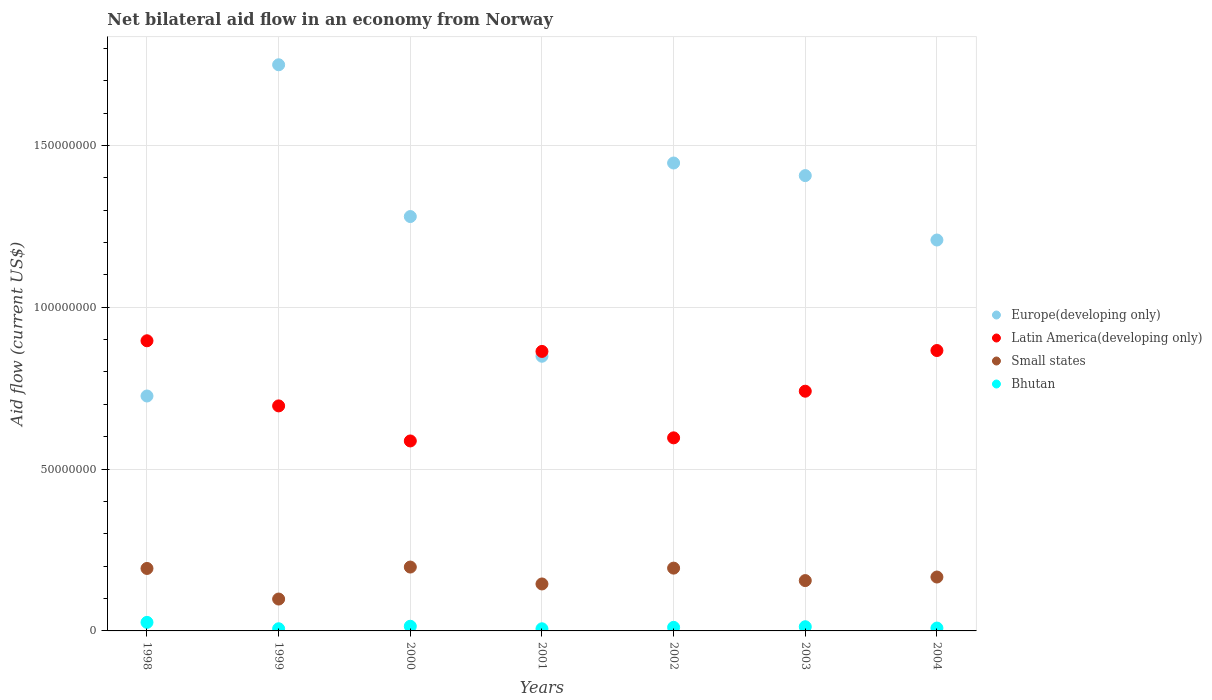How many different coloured dotlines are there?
Your answer should be very brief. 4. Is the number of dotlines equal to the number of legend labels?
Offer a very short reply. Yes. What is the net bilateral aid flow in Small states in 2001?
Keep it short and to the point. 1.45e+07. Across all years, what is the maximum net bilateral aid flow in Latin America(developing only)?
Offer a very short reply. 8.96e+07. What is the total net bilateral aid flow in Latin America(developing only) in the graph?
Keep it short and to the point. 5.25e+08. What is the difference between the net bilateral aid flow in Europe(developing only) in 1998 and that in 2002?
Provide a succinct answer. -7.20e+07. What is the difference between the net bilateral aid flow in Europe(developing only) in 2004 and the net bilateral aid flow in Bhutan in 2000?
Keep it short and to the point. 1.19e+08. What is the average net bilateral aid flow in Bhutan per year?
Provide a short and direct response. 1.24e+06. In the year 2000, what is the difference between the net bilateral aid flow in Europe(developing only) and net bilateral aid flow in Latin America(developing only)?
Ensure brevity in your answer.  6.93e+07. What is the ratio of the net bilateral aid flow in Small states in 1999 to that in 2003?
Offer a very short reply. 0.63. Is the difference between the net bilateral aid flow in Europe(developing only) in 1998 and 2004 greater than the difference between the net bilateral aid flow in Latin America(developing only) in 1998 and 2004?
Your answer should be very brief. No. What is the difference between the highest and the second highest net bilateral aid flow in Latin America(developing only)?
Your answer should be very brief. 3.01e+06. What is the difference between the highest and the lowest net bilateral aid flow in Small states?
Your answer should be very brief. 9.88e+06. Is it the case that in every year, the sum of the net bilateral aid flow in Bhutan and net bilateral aid flow in Europe(developing only)  is greater than the net bilateral aid flow in Latin America(developing only)?
Keep it short and to the point. No. Is the net bilateral aid flow in Latin America(developing only) strictly less than the net bilateral aid flow in Europe(developing only) over the years?
Provide a succinct answer. No. How many years are there in the graph?
Offer a very short reply. 7. What is the difference between two consecutive major ticks on the Y-axis?
Your answer should be very brief. 5.00e+07. Where does the legend appear in the graph?
Provide a succinct answer. Center right. How many legend labels are there?
Provide a succinct answer. 4. How are the legend labels stacked?
Provide a succinct answer. Vertical. What is the title of the graph?
Ensure brevity in your answer.  Net bilateral aid flow in an economy from Norway. Does "Cameroon" appear as one of the legend labels in the graph?
Offer a terse response. No. What is the Aid flow (current US$) in Europe(developing only) in 1998?
Make the answer very short. 7.26e+07. What is the Aid flow (current US$) in Latin America(developing only) in 1998?
Give a very brief answer. 8.96e+07. What is the Aid flow (current US$) of Small states in 1998?
Your answer should be very brief. 1.93e+07. What is the Aid flow (current US$) in Bhutan in 1998?
Offer a very short reply. 2.64e+06. What is the Aid flow (current US$) of Europe(developing only) in 1999?
Your response must be concise. 1.75e+08. What is the Aid flow (current US$) of Latin America(developing only) in 1999?
Provide a short and direct response. 6.95e+07. What is the Aid flow (current US$) of Small states in 1999?
Provide a short and direct response. 9.85e+06. What is the Aid flow (current US$) in Bhutan in 1999?
Your response must be concise. 6.70e+05. What is the Aid flow (current US$) of Europe(developing only) in 2000?
Offer a very short reply. 1.28e+08. What is the Aid flow (current US$) of Latin America(developing only) in 2000?
Make the answer very short. 5.87e+07. What is the Aid flow (current US$) of Small states in 2000?
Your answer should be very brief. 1.97e+07. What is the Aid flow (current US$) in Bhutan in 2000?
Your answer should be very brief. 1.44e+06. What is the Aid flow (current US$) of Europe(developing only) in 2001?
Ensure brevity in your answer.  8.49e+07. What is the Aid flow (current US$) in Latin America(developing only) in 2001?
Your response must be concise. 8.64e+07. What is the Aid flow (current US$) of Small states in 2001?
Provide a short and direct response. 1.45e+07. What is the Aid flow (current US$) in Europe(developing only) in 2002?
Keep it short and to the point. 1.45e+08. What is the Aid flow (current US$) in Latin America(developing only) in 2002?
Your answer should be very brief. 5.96e+07. What is the Aid flow (current US$) in Small states in 2002?
Your response must be concise. 1.94e+07. What is the Aid flow (current US$) in Bhutan in 2002?
Offer a very short reply. 1.10e+06. What is the Aid flow (current US$) of Europe(developing only) in 2003?
Ensure brevity in your answer.  1.41e+08. What is the Aid flow (current US$) in Latin America(developing only) in 2003?
Your answer should be very brief. 7.41e+07. What is the Aid flow (current US$) of Small states in 2003?
Ensure brevity in your answer.  1.56e+07. What is the Aid flow (current US$) in Bhutan in 2003?
Ensure brevity in your answer.  1.29e+06. What is the Aid flow (current US$) in Europe(developing only) in 2004?
Provide a succinct answer. 1.21e+08. What is the Aid flow (current US$) of Latin America(developing only) in 2004?
Ensure brevity in your answer.  8.66e+07. What is the Aid flow (current US$) of Small states in 2004?
Give a very brief answer. 1.66e+07. What is the Aid flow (current US$) of Bhutan in 2004?
Your response must be concise. 8.80e+05. Across all years, what is the maximum Aid flow (current US$) in Europe(developing only)?
Your answer should be very brief. 1.75e+08. Across all years, what is the maximum Aid flow (current US$) of Latin America(developing only)?
Your answer should be compact. 8.96e+07. Across all years, what is the maximum Aid flow (current US$) in Small states?
Offer a terse response. 1.97e+07. Across all years, what is the maximum Aid flow (current US$) of Bhutan?
Ensure brevity in your answer.  2.64e+06. Across all years, what is the minimum Aid flow (current US$) in Europe(developing only)?
Offer a very short reply. 7.26e+07. Across all years, what is the minimum Aid flow (current US$) in Latin America(developing only)?
Offer a very short reply. 5.87e+07. Across all years, what is the minimum Aid flow (current US$) of Small states?
Give a very brief answer. 9.85e+06. What is the total Aid flow (current US$) of Europe(developing only) in the graph?
Ensure brevity in your answer.  8.66e+08. What is the total Aid flow (current US$) of Latin America(developing only) in the graph?
Your answer should be very brief. 5.25e+08. What is the total Aid flow (current US$) in Small states in the graph?
Offer a terse response. 1.15e+08. What is the total Aid flow (current US$) of Bhutan in the graph?
Your answer should be compact. 8.68e+06. What is the difference between the Aid flow (current US$) in Europe(developing only) in 1998 and that in 1999?
Your answer should be very brief. -1.02e+08. What is the difference between the Aid flow (current US$) of Latin America(developing only) in 1998 and that in 1999?
Provide a short and direct response. 2.01e+07. What is the difference between the Aid flow (current US$) of Small states in 1998 and that in 1999?
Your answer should be very brief. 9.45e+06. What is the difference between the Aid flow (current US$) of Bhutan in 1998 and that in 1999?
Provide a short and direct response. 1.97e+06. What is the difference between the Aid flow (current US$) of Europe(developing only) in 1998 and that in 2000?
Ensure brevity in your answer.  -5.54e+07. What is the difference between the Aid flow (current US$) of Latin America(developing only) in 1998 and that in 2000?
Your answer should be very brief. 3.10e+07. What is the difference between the Aid flow (current US$) of Small states in 1998 and that in 2000?
Ensure brevity in your answer.  -4.30e+05. What is the difference between the Aid flow (current US$) in Bhutan in 1998 and that in 2000?
Offer a terse response. 1.20e+06. What is the difference between the Aid flow (current US$) of Europe(developing only) in 1998 and that in 2001?
Your answer should be very brief. -1.23e+07. What is the difference between the Aid flow (current US$) of Latin America(developing only) in 1998 and that in 2001?
Make the answer very short. 3.29e+06. What is the difference between the Aid flow (current US$) in Small states in 1998 and that in 2001?
Make the answer very short. 4.79e+06. What is the difference between the Aid flow (current US$) of Bhutan in 1998 and that in 2001?
Offer a very short reply. 1.98e+06. What is the difference between the Aid flow (current US$) of Europe(developing only) in 1998 and that in 2002?
Ensure brevity in your answer.  -7.20e+07. What is the difference between the Aid flow (current US$) of Latin America(developing only) in 1998 and that in 2002?
Offer a terse response. 3.00e+07. What is the difference between the Aid flow (current US$) in Bhutan in 1998 and that in 2002?
Your answer should be compact. 1.54e+06. What is the difference between the Aid flow (current US$) in Europe(developing only) in 1998 and that in 2003?
Your answer should be compact. -6.81e+07. What is the difference between the Aid flow (current US$) of Latin America(developing only) in 1998 and that in 2003?
Your answer should be compact. 1.56e+07. What is the difference between the Aid flow (current US$) in Small states in 1998 and that in 2003?
Ensure brevity in your answer.  3.75e+06. What is the difference between the Aid flow (current US$) of Bhutan in 1998 and that in 2003?
Provide a succinct answer. 1.35e+06. What is the difference between the Aid flow (current US$) in Europe(developing only) in 1998 and that in 2004?
Offer a terse response. -4.82e+07. What is the difference between the Aid flow (current US$) of Latin America(developing only) in 1998 and that in 2004?
Give a very brief answer. 3.01e+06. What is the difference between the Aid flow (current US$) of Small states in 1998 and that in 2004?
Offer a terse response. 2.65e+06. What is the difference between the Aid flow (current US$) of Bhutan in 1998 and that in 2004?
Your answer should be very brief. 1.76e+06. What is the difference between the Aid flow (current US$) of Europe(developing only) in 1999 and that in 2000?
Offer a very short reply. 4.69e+07. What is the difference between the Aid flow (current US$) of Latin America(developing only) in 1999 and that in 2000?
Keep it short and to the point. 1.08e+07. What is the difference between the Aid flow (current US$) of Small states in 1999 and that in 2000?
Keep it short and to the point. -9.88e+06. What is the difference between the Aid flow (current US$) in Bhutan in 1999 and that in 2000?
Make the answer very short. -7.70e+05. What is the difference between the Aid flow (current US$) of Europe(developing only) in 1999 and that in 2001?
Provide a short and direct response. 9.00e+07. What is the difference between the Aid flow (current US$) of Latin America(developing only) in 1999 and that in 2001?
Give a very brief answer. -1.68e+07. What is the difference between the Aid flow (current US$) in Small states in 1999 and that in 2001?
Your response must be concise. -4.66e+06. What is the difference between the Aid flow (current US$) of Bhutan in 1999 and that in 2001?
Give a very brief answer. 10000. What is the difference between the Aid flow (current US$) of Europe(developing only) in 1999 and that in 2002?
Provide a succinct answer. 3.04e+07. What is the difference between the Aid flow (current US$) of Latin America(developing only) in 1999 and that in 2002?
Your response must be concise. 9.87e+06. What is the difference between the Aid flow (current US$) of Small states in 1999 and that in 2002?
Your answer should be compact. -9.55e+06. What is the difference between the Aid flow (current US$) in Bhutan in 1999 and that in 2002?
Make the answer very short. -4.30e+05. What is the difference between the Aid flow (current US$) in Europe(developing only) in 1999 and that in 2003?
Your answer should be very brief. 3.42e+07. What is the difference between the Aid flow (current US$) in Latin America(developing only) in 1999 and that in 2003?
Ensure brevity in your answer.  -4.54e+06. What is the difference between the Aid flow (current US$) of Small states in 1999 and that in 2003?
Make the answer very short. -5.70e+06. What is the difference between the Aid flow (current US$) of Bhutan in 1999 and that in 2003?
Offer a terse response. -6.20e+05. What is the difference between the Aid flow (current US$) in Europe(developing only) in 1999 and that in 2004?
Provide a succinct answer. 5.41e+07. What is the difference between the Aid flow (current US$) of Latin America(developing only) in 1999 and that in 2004?
Give a very brief answer. -1.71e+07. What is the difference between the Aid flow (current US$) in Small states in 1999 and that in 2004?
Provide a short and direct response. -6.80e+06. What is the difference between the Aid flow (current US$) in Bhutan in 1999 and that in 2004?
Provide a succinct answer. -2.10e+05. What is the difference between the Aid flow (current US$) in Europe(developing only) in 2000 and that in 2001?
Ensure brevity in your answer.  4.32e+07. What is the difference between the Aid flow (current US$) of Latin America(developing only) in 2000 and that in 2001?
Your answer should be compact. -2.77e+07. What is the difference between the Aid flow (current US$) of Small states in 2000 and that in 2001?
Provide a short and direct response. 5.22e+06. What is the difference between the Aid flow (current US$) of Bhutan in 2000 and that in 2001?
Provide a short and direct response. 7.80e+05. What is the difference between the Aid flow (current US$) in Europe(developing only) in 2000 and that in 2002?
Ensure brevity in your answer.  -1.65e+07. What is the difference between the Aid flow (current US$) of Latin America(developing only) in 2000 and that in 2002?
Make the answer very short. -9.60e+05. What is the difference between the Aid flow (current US$) of Small states in 2000 and that in 2002?
Your answer should be very brief. 3.30e+05. What is the difference between the Aid flow (current US$) of Europe(developing only) in 2000 and that in 2003?
Your answer should be compact. -1.26e+07. What is the difference between the Aid flow (current US$) of Latin America(developing only) in 2000 and that in 2003?
Keep it short and to the point. -1.54e+07. What is the difference between the Aid flow (current US$) of Small states in 2000 and that in 2003?
Keep it short and to the point. 4.18e+06. What is the difference between the Aid flow (current US$) in Bhutan in 2000 and that in 2003?
Your answer should be compact. 1.50e+05. What is the difference between the Aid flow (current US$) in Europe(developing only) in 2000 and that in 2004?
Your answer should be very brief. 7.25e+06. What is the difference between the Aid flow (current US$) of Latin America(developing only) in 2000 and that in 2004?
Keep it short and to the point. -2.79e+07. What is the difference between the Aid flow (current US$) of Small states in 2000 and that in 2004?
Your answer should be compact. 3.08e+06. What is the difference between the Aid flow (current US$) in Bhutan in 2000 and that in 2004?
Ensure brevity in your answer.  5.60e+05. What is the difference between the Aid flow (current US$) in Europe(developing only) in 2001 and that in 2002?
Provide a succinct answer. -5.97e+07. What is the difference between the Aid flow (current US$) in Latin America(developing only) in 2001 and that in 2002?
Your response must be concise. 2.67e+07. What is the difference between the Aid flow (current US$) in Small states in 2001 and that in 2002?
Provide a short and direct response. -4.89e+06. What is the difference between the Aid flow (current US$) of Bhutan in 2001 and that in 2002?
Give a very brief answer. -4.40e+05. What is the difference between the Aid flow (current US$) in Europe(developing only) in 2001 and that in 2003?
Provide a short and direct response. -5.58e+07. What is the difference between the Aid flow (current US$) in Latin America(developing only) in 2001 and that in 2003?
Your answer should be compact. 1.23e+07. What is the difference between the Aid flow (current US$) in Small states in 2001 and that in 2003?
Offer a very short reply. -1.04e+06. What is the difference between the Aid flow (current US$) of Bhutan in 2001 and that in 2003?
Keep it short and to the point. -6.30e+05. What is the difference between the Aid flow (current US$) in Europe(developing only) in 2001 and that in 2004?
Your answer should be compact. -3.59e+07. What is the difference between the Aid flow (current US$) in Latin America(developing only) in 2001 and that in 2004?
Offer a very short reply. -2.80e+05. What is the difference between the Aid flow (current US$) of Small states in 2001 and that in 2004?
Offer a terse response. -2.14e+06. What is the difference between the Aid flow (current US$) of Bhutan in 2001 and that in 2004?
Your answer should be very brief. -2.20e+05. What is the difference between the Aid flow (current US$) of Europe(developing only) in 2002 and that in 2003?
Make the answer very short. 3.89e+06. What is the difference between the Aid flow (current US$) of Latin America(developing only) in 2002 and that in 2003?
Make the answer very short. -1.44e+07. What is the difference between the Aid flow (current US$) of Small states in 2002 and that in 2003?
Keep it short and to the point. 3.85e+06. What is the difference between the Aid flow (current US$) of Bhutan in 2002 and that in 2003?
Ensure brevity in your answer.  -1.90e+05. What is the difference between the Aid flow (current US$) of Europe(developing only) in 2002 and that in 2004?
Provide a succinct answer. 2.38e+07. What is the difference between the Aid flow (current US$) of Latin America(developing only) in 2002 and that in 2004?
Your answer should be very brief. -2.70e+07. What is the difference between the Aid flow (current US$) in Small states in 2002 and that in 2004?
Give a very brief answer. 2.75e+06. What is the difference between the Aid flow (current US$) of Europe(developing only) in 2003 and that in 2004?
Your response must be concise. 1.99e+07. What is the difference between the Aid flow (current US$) in Latin America(developing only) in 2003 and that in 2004?
Ensure brevity in your answer.  -1.26e+07. What is the difference between the Aid flow (current US$) in Small states in 2003 and that in 2004?
Your response must be concise. -1.10e+06. What is the difference between the Aid flow (current US$) in Europe(developing only) in 1998 and the Aid flow (current US$) in Latin America(developing only) in 1999?
Provide a succinct answer. 3.06e+06. What is the difference between the Aid flow (current US$) in Europe(developing only) in 1998 and the Aid flow (current US$) in Small states in 1999?
Make the answer very short. 6.27e+07. What is the difference between the Aid flow (current US$) in Europe(developing only) in 1998 and the Aid flow (current US$) in Bhutan in 1999?
Offer a terse response. 7.19e+07. What is the difference between the Aid flow (current US$) of Latin America(developing only) in 1998 and the Aid flow (current US$) of Small states in 1999?
Keep it short and to the point. 7.98e+07. What is the difference between the Aid flow (current US$) in Latin America(developing only) in 1998 and the Aid flow (current US$) in Bhutan in 1999?
Ensure brevity in your answer.  8.90e+07. What is the difference between the Aid flow (current US$) in Small states in 1998 and the Aid flow (current US$) in Bhutan in 1999?
Provide a succinct answer. 1.86e+07. What is the difference between the Aid flow (current US$) in Europe(developing only) in 1998 and the Aid flow (current US$) in Latin America(developing only) in 2000?
Ensure brevity in your answer.  1.39e+07. What is the difference between the Aid flow (current US$) of Europe(developing only) in 1998 and the Aid flow (current US$) of Small states in 2000?
Your answer should be compact. 5.28e+07. What is the difference between the Aid flow (current US$) in Europe(developing only) in 1998 and the Aid flow (current US$) in Bhutan in 2000?
Offer a terse response. 7.11e+07. What is the difference between the Aid flow (current US$) of Latin America(developing only) in 1998 and the Aid flow (current US$) of Small states in 2000?
Offer a terse response. 6.99e+07. What is the difference between the Aid flow (current US$) in Latin America(developing only) in 1998 and the Aid flow (current US$) in Bhutan in 2000?
Ensure brevity in your answer.  8.82e+07. What is the difference between the Aid flow (current US$) in Small states in 1998 and the Aid flow (current US$) in Bhutan in 2000?
Ensure brevity in your answer.  1.79e+07. What is the difference between the Aid flow (current US$) in Europe(developing only) in 1998 and the Aid flow (current US$) in Latin America(developing only) in 2001?
Give a very brief answer. -1.38e+07. What is the difference between the Aid flow (current US$) in Europe(developing only) in 1998 and the Aid flow (current US$) in Small states in 2001?
Your answer should be very brief. 5.81e+07. What is the difference between the Aid flow (current US$) in Europe(developing only) in 1998 and the Aid flow (current US$) in Bhutan in 2001?
Provide a succinct answer. 7.19e+07. What is the difference between the Aid flow (current US$) of Latin America(developing only) in 1998 and the Aid flow (current US$) of Small states in 2001?
Provide a succinct answer. 7.51e+07. What is the difference between the Aid flow (current US$) in Latin America(developing only) in 1998 and the Aid flow (current US$) in Bhutan in 2001?
Your answer should be very brief. 8.90e+07. What is the difference between the Aid flow (current US$) in Small states in 1998 and the Aid flow (current US$) in Bhutan in 2001?
Provide a short and direct response. 1.86e+07. What is the difference between the Aid flow (current US$) in Europe(developing only) in 1998 and the Aid flow (current US$) in Latin America(developing only) in 2002?
Ensure brevity in your answer.  1.29e+07. What is the difference between the Aid flow (current US$) in Europe(developing only) in 1998 and the Aid flow (current US$) in Small states in 2002?
Offer a very short reply. 5.32e+07. What is the difference between the Aid flow (current US$) of Europe(developing only) in 1998 and the Aid flow (current US$) of Bhutan in 2002?
Make the answer very short. 7.15e+07. What is the difference between the Aid flow (current US$) of Latin America(developing only) in 1998 and the Aid flow (current US$) of Small states in 2002?
Provide a succinct answer. 7.02e+07. What is the difference between the Aid flow (current US$) in Latin America(developing only) in 1998 and the Aid flow (current US$) in Bhutan in 2002?
Offer a very short reply. 8.85e+07. What is the difference between the Aid flow (current US$) in Small states in 1998 and the Aid flow (current US$) in Bhutan in 2002?
Provide a succinct answer. 1.82e+07. What is the difference between the Aid flow (current US$) in Europe(developing only) in 1998 and the Aid flow (current US$) in Latin America(developing only) in 2003?
Keep it short and to the point. -1.48e+06. What is the difference between the Aid flow (current US$) of Europe(developing only) in 1998 and the Aid flow (current US$) of Small states in 2003?
Provide a short and direct response. 5.70e+07. What is the difference between the Aid flow (current US$) in Europe(developing only) in 1998 and the Aid flow (current US$) in Bhutan in 2003?
Your response must be concise. 7.13e+07. What is the difference between the Aid flow (current US$) in Latin America(developing only) in 1998 and the Aid flow (current US$) in Small states in 2003?
Provide a succinct answer. 7.41e+07. What is the difference between the Aid flow (current US$) in Latin America(developing only) in 1998 and the Aid flow (current US$) in Bhutan in 2003?
Provide a succinct answer. 8.84e+07. What is the difference between the Aid flow (current US$) in Small states in 1998 and the Aid flow (current US$) in Bhutan in 2003?
Your answer should be compact. 1.80e+07. What is the difference between the Aid flow (current US$) in Europe(developing only) in 1998 and the Aid flow (current US$) in Latin America(developing only) in 2004?
Make the answer very short. -1.40e+07. What is the difference between the Aid flow (current US$) of Europe(developing only) in 1998 and the Aid flow (current US$) of Small states in 2004?
Keep it short and to the point. 5.59e+07. What is the difference between the Aid flow (current US$) of Europe(developing only) in 1998 and the Aid flow (current US$) of Bhutan in 2004?
Provide a short and direct response. 7.17e+07. What is the difference between the Aid flow (current US$) of Latin America(developing only) in 1998 and the Aid flow (current US$) of Small states in 2004?
Provide a short and direct response. 7.30e+07. What is the difference between the Aid flow (current US$) in Latin America(developing only) in 1998 and the Aid flow (current US$) in Bhutan in 2004?
Your response must be concise. 8.88e+07. What is the difference between the Aid flow (current US$) of Small states in 1998 and the Aid flow (current US$) of Bhutan in 2004?
Your response must be concise. 1.84e+07. What is the difference between the Aid flow (current US$) in Europe(developing only) in 1999 and the Aid flow (current US$) in Latin America(developing only) in 2000?
Provide a short and direct response. 1.16e+08. What is the difference between the Aid flow (current US$) in Europe(developing only) in 1999 and the Aid flow (current US$) in Small states in 2000?
Your answer should be very brief. 1.55e+08. What is the difference between the Aid flow (current US$) of Europe(developing only) in 1999 and the Aid flow (current US$) of Bhutan in 2000?
Give a very brief answer. 1.73e+08. What is the difference between the Aid flow (current US$) in Latin America(developing only) in 1999 and the Aid flow (current US$) in Small states in 2000?
Ensure brevity in your answer.  4.98e+07. What is the difference between the Aid flow (current US$) in Latin America(developing only) in 1999 and the Aid flow (current US$) in Bhutan in 2000?
Your answer should be very brief. 6.81e+07. What is the difference between the Aid flow (current US$) in Small states in 1999 and the Aid flow (current US$) in Bhutan in 2000?
Ensure brevity in your answer.  8.41e+06. What is the difference between the Aid flow (current US$) in Europe(developing only) in 1999 and the Aid flow (current US$) in Latin America(developing only) in 2001?
Give a very brief answer. 8.86e+07. What is the difference between the Aid flow (current US$) in Europe(developing only) in 1999 and the Aid flow (current US$) in Small states in 2001?
Your answer should be compact. 1.60e+08. What is the difference between the Aid flow (current US$) in Europe(developing only) in 1999 and the Aid flow (current US$) in Bhutan in 2001?
Ensure brevity in your answer.  1.74e+08. What is the difference between the Aid flow (current US$) of Latin America(developing only) in 1999 and the Aid flow (current US$) of Small states in 2001?
Ensure brevity in your answer.  5.50e+07. What is the difference between the Aid flow (current US$) of Latin America(developing only) in 1999 and the Aid flow (current US$) of Bhutan in 2001?
Provide a short and direct response. 6.89e+07. What is the difference between the Aid flow (current US$) in Small states in 1999 and the Aid flow (current US$) in Bhutan in 2001?
Provide a short and direct response. 9.19e+06. What is the difference between the Aid flow (current US$) in Europe(developing only) in 1999 and the Aid flow (current US$) in Latin America(developing only) in 2002?
Provide a succinct answer. 1.15e+08. What is the difference between the Aid flow (current US$) of Europe(developing only) in 1999 and the Aid flow (current US$) of Small states in 2002?
Make the answer very short. 1.56e+08. What is the difference between the Aid flow (current US$) of Europe(developing only) in 1999 and the Aid flow (current US$) of Bhutan in 2002?
Make the answer very short. 1.74e+08. What is the difference between the Aid flow (current US$) of Latin America(developing only) in 1999 and the Aid flow (current US$) of Small states in 2002?
Give a very brief answer. 5.01e+07. What is the difference between the Aid flow (current US$) of Latin America(developing only) in 1999 and the Aid flow (current US$) of Bhutan in 2002?
Ensure brevity in your answer.  6.84e+07. What is the difference between the Aid flow (current US$) of Small states in 1999 and the Aid flow (current US$) of Bhutan in 2002?
Ensure brevity in your answer.  8.75e+06. What is the difference between the Aid flow (current US$) in Europe(developing only) in 1999 and the Aid flow (current US$) in Latin America(developing only) in 2003?
Ensure brevity in your answer.  1.01e+08. What is the difference between the Aid flow (current US$) of Europe(developing only) in 1999 and the Aid flow (current US$) of Small states in 2003?
Your answer should be very brief. 1.59e+08. What is the difference between the Aid flow (current US$) of Europe(developing only) in 1999 and the Aid flow (current US$) of Bhutan in 2003?
Give a very brief answer. 1.74e+08. What is the difference between the Aid flow (current US$) in Latin America(developing only) in 1999 and the Aid flow (current US$) in Small states in 2003?
Offer a terse response. 5.40e+07. What is the difference between the Aid flow (current US$) in Latin America(developing only) in 1999 and the Aid flow (current US$) in Bhutan in 2003?
Ensure brevity in your answer.  6.82e+07. What is the difference between the Aid flow (current US$) of Small states in 1999 and the Aid flow (current US$) of Bhutan in 2003?
Your answer should be compact. 8.56e+06. What is the difference between the Aid flow (current US$) in Europe(developing only) in 1999 and the Aid flow (current US$) in Latin America(developing only) in 2004?
Ensure brevity in your answer.  8.83e+07. What is the difference between the Aid flow (current US$) in Europe(developing only) in 1999 and the Aid flow (current US$) in Small states in 2004?
Provide a succinct answer. 1.58e+08. What is the difference between the Aid flow (current US$) in Europe(developing only) in 1999 and the Aid flow (current US$) in Bhutan in 2004?
Offer a very short reply. 1.74e+08. What is the difference between the Aid flow (current US$) of Latin America(developing only) in 1999 and the Aid flow (current US$) of Small states in 2004?
Provide a succinct answer. 5.29e+07. What is the difference between the Aid flow (current US$) in Latin America(developing only) in 1999 and the Aid flow (current US$) in Bhutan in 2004?
Ensure brevity in your answer.  6.86e+07. What is the difference between the Aid flow (current US$) in Small states in 1999 and the Aid flow (current US$) in Bhutan in 2004?
Your answer should be very brief. 8.97e+06. What is the difference between the Aid flow (current US$) in Europe(developing only) in 2000 and the Aid flow (current US$) in Latin America(developing only) in 2001?
Your answer should be very brief. 4.17e+07. What is the difference between the Aid flow (current US$) of Europe(developing only) in 2000 and the Aid flow (current US$) of Small states in 2001?
Your answer should be very brief. 1.14e+08. What is the difference between the Aid flow (current US$) of Europe(developing only) in 2000 and the Aid flow (current US$) of Bhutan in 2001?
Your answer should be compact. 1.27e+08. What is the difference between the Aid flow (current US$) of Latin America(developing only) in 2000 and the Aid flow (current US$) of Small states in 2001?
Provide a short and direct response. 4.42e+07. What is the difference between the Aid flow (current US$) in Latin America(developing only) in 2000 and the Aid flow (current US$) in Bhutan in 2001?
Offer a very short reply. 5.80e+07. What is the difference between the Aid flow (current US$) in Small states in 2000 and the Aid flow (current US$) in Bhutan in 2001?
Your response must be concise. 1.91e+07. What is the difference between the Aid flow (current US$) in Europe(developing only) in 2000 and the Aid flow (current US$) in Latin America(developing only) in 2002?
Provide a short and direct response. 6.84e+07. What is the difference between the Aid flow (current US$) in Europe(developing only) in 2000 and the Aid flow (current US$) in Small states in 2002?
Provide a succinct answer. 1.09e+08. What is the difference between the Aid flow (current US$) in Europe(developing only) in 2000 and the Aid flow (current US$) in Bhutan in 2002?
Make the answer very short. 1.27e+08. What is the difference between the Aid flow (current US$) of Latin America(developing only) in 2000 and the Aid flow (current US$) of Small states in 2002?
Ensure brevity in your answer.  3.93e+07. What is the difference between the Aid flow (current US$) in Latin America(developing only) in 2000 and the Aid flow (current US$) in Bhutan in 2002?
Offer a very short reply. 5.76e+07. What is the difference between the Aid flow (current US$) in Small states in 2000 and the Aid flow (current US$) in Bhutan in 2002?
Offer a terse response. 1.86e+07. What is the difference between the Aid flow (current US$) in Europe(developing only) in 2000 and the Aid flow (current US$) in Latin America(developing only) in 2003?
Offer a very short reply. 5.40e+07. What is the difference between the Aid flow (current US$) of Europe(developing only) in 2000 and the Aid flow (current US$) of Small states in 2003?
Your response must be concise. 1.12e+08. What is the difference between the Aid flow (current US$) in Europe(developing only) in 2000 and the Aid flow (current US$) in Bhutan in 2003?
Your response must be concise. 1.27e+08. What is the difference between the Aid flow (current US$) in Latin America(developing only) in 2000 and the Aid flow (current US$) in Small states in 2003?
Provide a short and direct response. 4.31e+07. What is the difference between the Aid flow (current US$) of Latin America(developing only) in 2000 and the Aid flow (current US$) of Bhutan in 2003?
Offer a very short reply. 5.74e+07. What is the difference between the Aid flow (current US$) in Small states in 2000 and the Aid flow (current US$) in Bhutan in 2003?
Your answer should be very brief. 1.84e+07. What is the difference between the Aid flow (current US$) in Europe(developing only) in 2000 and the Aid flow (current US$) in Latin America(developing only) in 2004?
Provide a short and direct response. 4.14e+07. What is the difference between the Aid flow (current US$) of Europe(developing only) in 2000 and the Aid flow (current US$) of Small states in 2004?
Offer a very short reply. 1.11e+08. What is the difference between the Aid flow (current US$) of Europe(developing only) in 2000 and the Aid flow (current US$) of Bhutan in 2004?
Ensure brevity in your answer.  1.27e+08. What is the difference between the Aid flow (current US$) in Latin America(developing only) in 2000 and the Aid flow (current US$) in Small states in 2004?
Your answer should be compact. 4.20e+07. What is the difference between the Aid flow (current US$) of Latin America(developing only) in 2000 and the Aid flow (current US$) of Bhutan in 2004?
Provide a short and direct response. 5.78e+07. What is the difference between the Aid flow (current US$) of Small states in 2000 and the Aid flow (current US$) of Bhutan in 2004?
Offer a terse response. 1.88e+07. What is the difference between the Aid flow (current US$) of Europe(developing only) in 2001 and the Aid flow (current US$) of Latin America(developing only) in 2002?
Your answer should be very brief. 2.52e+07. What is the difference between the Aid flow (current US$) in Europe(developing only) in 2001 and the Aid flow (current US$) in Small states in 2002?
Your answer should be compact. 6.55e+07. What is the difference between the Aid flow (current US$) in Europe(developing only) in 2001 and the Aid flow (current US$) in Bhutan in 2002?
Your answer should be compact. 8.38e+07. What is the difference between the Aid flow (current US$) of Latin America(developing only) in 2001 and the Aid flow (current US$) of Small states in 2002?
Provide a short and direct response. 6.70e+07. What is the difference between the Aid flow (current US$) in Latin America(developing only) in 2001 and the Aid flow (current US$) in Bhutan in 2002?
Offer a very short reply. 8.52e+07. What is the difference between the Aid flow (current US$) of Small states in 2001 and the Aid flow (current US$) of Bhutan in 2002?
Your answer should be very brief. 1.34e+07. What is the difference between the Aid flow (current US$) of Europe(developing only) in 2001 and the Aid flow (current US$) of Latin America(developing only) in 2003?
Your answer should be compact. 1.08e+07. What is the difference between the Aid flow (current US$) of Europe(developing only) in 2001 and the Aid flow (current US$) of Small states in 2003?
Your answer should be very brief. 6.93e+07. What is the difference between the Aid flow (current US$) in Europe(developing only) in 2001 and the Aid flow (current US$) in Bhutan in 2003?
Offer a terse response. 8.36e+07. What is the difference between the Aid flow (current US$) in Latin America(developing only) in 2001 and the Aid flow (current US$) in Small states in 2003?
Keep it short and to the point. 7.08e+07. What is the difference between the Aid flow (current US$) of Latin America(developing only) in 2001 and the Aid flow (current US$) of Bhutan in 2003?
Give a very brief answer. 8.51e+07. What is the difference between the Aid flow (current US$) in Small states in 2001 and the Aid flow (current US$) in Bhutan in 2003?
Your answer should be compact. 1.32e+07. What is the difference between the Aid flow (current US$) in Europe(developing only) in 2001 and the Aid flow (current US$) in Latin America(developing only) in 2004?
Offer a terse response. -1.77e+06. What is the difference between the Aid flow (current US$) in Europe(developing only) in 2001 and the Aid flow (current US$) in Small states in 2004?
Offer a terse response. 6.82e+07. What is the difference between the Aid flow (current US$) of Europe(developing only) in 2001 and the Aid flow (current US$) of Bhutan in 2004?
Keep it short and to the point. 8.40e+07. What is the difference between the Aid flow (current US$) in Latin America(developing only) in 2001 and the Aid flow (current US$) in Small states in 2004?
Offer a very short reply. 6.97e+07. What is the difference between the Aid flow (current US$) in Latin America(developing only) in 2001 and the Aid flow (current US$) in Bhutan in 2004?
Ensure brevity in your answer.  8.55e+07. What is the difference between the Aid flow (current US$) of Small states in 2001 and the Aid flow (current US$) of Bhutan in 2004?
Your response must be concise. 1.36e+07. What is the difference between the Aid flow (current US$) in Europe(developing only) in 2002 and the Aid flow (current US$) in Latin America(developing only) in 2003?
Provide a short and direct response. 7.05e+07. What is the difference between the Aid flow (current US$) of Europe(developing only) in 2002 and the Aid flow (current US$) of Small states in 2003?
Your answer should be very brief. 1.29e+08. What is the difference between the Aid flow (current US$) of Europe(developing only) in 2002 and the Aid flow (current US$) of Bhutan in 2003?
Provide a succinct answer. 1.43e+08. What is the difference between the Aid flow (current US$) of Latin America(developing only) in 2002 and the Aid flow (current US$) of Small states in 2003?
Offer a terse response. 4.41e+07. What is the difference between the Aid flow (current US$) in Latin America(developing only) in 2002 and the Aid flow (current US$) in Bhutan in 2003?
Provide a short and direct response. 5.84e+07. What is the difference between the Aid flow (current US$) in Small states in 2002 and the Aid flow (current US$) in Bhutan in 2003?
Keep it short and to the point. 1.81e+07. What is the difference between the Aid flow (current US$) in Europe(developing only) in 2002 and the Aid flow (current US$) in Latin America(developing only) in 2004?
Provide a succinct answer. 5.79e+07. What is the difference between the Aid flow (current US$) of Europe(developing only) in 2002 and the Aid flow (current US$) of Small states in 2004?
Your answer should be very brief. 1.28e+08. What is the difference between the Aid flow (current US$) in Europe(developing only) in 2002 and the Aid flow (current US$) in Bhutan in 2004?
Your response must be concise. 1.44e+08. What is the difference between the Aid flow (current US$) of Latin America(developing only) in 2002 and the Aid flow (current US$) of Small states in 2004?
Ensure brevity in your answer.  4.30e+07. What is the difference between the Aid flow (current US$) in Latin America(developing only) in 2002 and the Aid flow (current US$) in Bhutan in 2004?
Keep it short and to the point. 5.88e+07. What is the difference between the Aid flow (current US$) of Small states in 2002 and the Aid flow (current US$) of Bhutan in 2004?
Offer a very short reply. 1.85e+07. What is the difference between the Aid flow (current US$) in Europe(developing only) in 2003 and the Aid flow (current US$) in Latin America(developing only) in 2004?
Keep it short and to the point. 5.40e+07. What is the difference between the Aid flow (current US$) of Europe(developing only) in 2003 and the Aid flow (current US$) of Small states in 2004?
Provide a short and direct response. 1.24e+08. What is the difference between the Aid flow (current US$) of Europe(developing only) in 2003 and the Aid flow (current US$) of Bhutan in 2004?
Ensure brevity in your answer.  1.40e+08. What is the difference between the Aid flow (current US$) in Latin America(developing only) in 2003 and the Aid flow (current US$) in Small states in 2004?
Provide a succinct answer. 5.74e+07. What is the difference between the Aid flow (current US$) in Latin America(developing only) in 2003 and the Aid flow (current US$) in Bhutan in 2004?
Provide a succinct answer. 7.32e+07. What is the difference between the Aid flow (current US$) in Small states in 2003 and the Aid flow (current US$) in Bhutan in 2004?
Provide a short and direct response. 1.47e+07. What is the average Aid flow (current US$) of Europe(developing only) per year?
Your response must be concise. 1.24e+08. What is the average Aid flow (current US$) of Latin America(developing only) per year?
Keep it short and to the point. 7.49e+07. What is the average Aid flow (current US$) in Small states per year?
Your response must be concise. 1.64e+07. What is the average Aid flow (current US$) of Bhutan per year?
Your answer should be compact. 1.24e+06. In the year 1998, what is the difference between the Aid flow (current US$) in Europe(developing only) and Aid flow (current US$) in Latin America(developing only)?
Ensure brevity in your answer.  -1.71e+07. In the year 1998, what is the difference between the Aid flow (current US$) of Europe(developing only) and Aid flow (current US$) of Small states?
Your answer should be compact. 5.33e+07. In the year 1998, what is the difference between the Aid flow (current US$) of Europe(developing only) and Aid flow (current US$) of Bhutan?
Your answer should be compact. 6.99e+07. In the year 1998, what is the difference between the Aid flow (current US$) of Latin America(developing only) and Aid flow (current US$) of Small states?
Your response must be concise. 7.03e+07. In the year 1998, what is the difference between the Aid flow (current US$) in Latin America(developing only) and Aid flow (current US$) in Bhutan?
Ensure brevity in your answer.  8.70e+07. In the year 1998, what is the difference between the Aid flow (current US$) in Small states and Aid flow (current US$) in Bhutan?
Your answer should be compact. 1.67e+07. In the year 1999, what is the difference between the Aid flow (current US$) of Europe(developing only) and Aid flow (current US$) of Latin America(developing only)?
Ensure brevity in your answer.  1.05e+08. In the year 1999, what is the difference between the Aid flow (current US$) in Europe(developing only) and Aid flow (current US$) in Small states?
Keep it short and to the point. 1.65e+08. In the year 1999, what is the difference between the Aid flow (current US$) of Europe(developing only) and Aid flow (current US$) of Bhutan?
Offer a terse response. 1.74e+08. In the year 1999, what is the difference between the Aid flow (current US$) in Latin America(developing only) and Aid flow (current US$) in Small states?
Give a very brief answer. 5.97e+07. In the year 1999, what is the difference between the Aid flow (current US$) of Latin America(developing only) and Aid flow (current US$) of Bhutan?
Offer a very short reply. 6.88e+07. In the year 1999, what is the difference between the Aid flow (current US$) in Small states and Aid flow (current US$) in Bhutan?
Offer a terse response. 9.18e+06. In the year 2000, what is the difference between the Aid flow (current US$) of Europe(developing only) and Aid flow (current US$) of Latin America(developing only)?
Provide a short and direct response. 6.93e+07. In the year 2000, what is the difference between the Aid flow (current US$) in Europe(developing only) and Aid flow (current US$) in Small states?
Your answer should be compact. 1.08e+08. In the year 2000, what is the difference between the Aid flow (current US$) of Europe(developing only) and Aid flow (current US$) of Bhutan?
Make the answer very short. 1.27e+08. In the year 2000, what is the difference between the Aid flow (current US$) in Latin America(developing only) and Aid flow (current US$) in Small states?
Your answer should be very brief. 3.90e+07. In the year 2000, what is the difference between the Aid flow (current US$) in Latin America(developing only) and Aid flow (current US$) in Bhutan?
Make the answer very short. 5.72e+07. In the year 2000, what is the difference between the Aid flow (current US$) in Small states and Aid flow (current US$) in Bhutan?
Provide a short and direct response. 1.83e+07. In the year 2001, what is the difference between the Aid flow (current US$) in Europe(developing only) and Aid flow (current US$) in Latin America(developing only)?
Your answer should be compact. -1.49e+06. In the year 2001, what is the difference between the Aid flow (current US$) of Europe(developing only) and Aid flow (current US$) of Small states?
Offer a terse response. 7.04e+07. In the year 2001, what is the difference between the Aid flow (current US$) in Europe(developing only) and Aid flow (current US$) in Bhutan?
Offer a terse response. 8.42e+07. In the year 2001, what is the difference between the Aid flow (current US$) in Latin America(developing only) and Aid flow (current US$) in Small states?
Ensure brevity in your answer.  7.18e+07. In the year 2001, what is the difference between the Aid flow (current US$) in Latin America(developing only) and Aid flow (current US$) in Bhutan?
Give a very brief answer. 8.57e+07. In the year 2001, what is the difference between the Aid flow (current US$) of Small states and Aid flow (current US$) of Bhutan?
Your answer should be very brief. 1.38e+07. In the year 2002, what is the difference between the Aid flow (current US$) in Europe(developing only) and Aid flow (current US$) in Latin America(developing only)?
Make the answer very short. 8.49e+07. In the year 2002, what is the difference between the Aid flow (current US$) in Europe(developing only) and Aid flow (current US$) in Small states?
Provide a short and direct response. 1.25e+08. In the year 2002, what is the difference between the Aid flow (current US$) in Europe(developing only) and Aid flow (current US$) in Bhutan?
Make the answer very short. 1.43e+08. In the year 2002, what is the difference between the Aid flow (current US$) of Latin America(developing only) and Aid flow (current US$) of Small states?
Offer a very short reply. 4.02e+07. In the year 2002, what is the difference between the Aid flow (current US$) in Latin America(developing only) and Aid flow (current US$) in Bhutan?
Your response must be concise. 5.86e+07. In the year 2002, what is the difference between the Aid flow (current US$) in Small states and Aid flow (current US$) in Bhutan?
Your response must be concise. 1.83e+07. In the year 2003, what is the difference between the Aid flow (current US$) in Europe(developing only) and Aid flow (current US$) in Latin America(developing only)?
Make the answer very short. 6.66e+07. In the year 2003, what is the difference between the Aid flow (current US$) in Europe(developing only) and Aid flow (current US$) in Small states?
Ensure brevity in your answer.  1.25e+08. In the year 2003, what is the difference between the Aid flow (current US$) in Europe(developing only) and Aid flow (current US$) in Bhutan?
Offer a terse response. 1.39e+08. In the year 2003, what is the difference between the Aid flow (current US$) of Latin America(developing only) and Aid flow (current US$) of Small states?
Ensure brevity in your answer.  5.85e+07. In the year 2003, what is the difference between the Aid flow (current US$) of Latin America(developing only) and Aid flow (current US$) of Bhutan?
Your response must be concise. 7.28e+07. In the year 2003, what is the difference between the Aid flow (current US$) of Small states and Aid flow (current US$) of Bhutan?
Offer a terse response. 1.43e+07. In the year 2004, what is the difference between the Aid flow (current US$) in Europe(developing only) and Aid flow (current US$) in Latin America(developing only)?
Your answer should be very brief. 3.41e+07. In the year 2004, what is the difference between the Aid flow (current US$) in Europe(developing only) and Aid flow (current US$) in Small states?
Make the answer very short. 1.04e+08. In the year 2004, what is the difference between the Aid flow (current US$) in Europe(developing only) and Aid flow (current US$) in Bhutan?
Keep it short and to the point. 1.20e+08. In the year 2004, what is the difference between the Aid flow (current US$) in Latin America(developing only) and Aid flow (current US$) in Small states?
Offer a very short reply. 7.00e+07. In the year 2004, what is the difference between the Aid flow (current US$) in Latin America(developing only) and Aid flow (current US$) in Bhutan?
Your answer should be compact. 8.58e+07. In the year 2004, what is the difference between the Aid flow (current US$) in Small states and Aid flow (current US$) in Bhutan?
Your answer should be very brief. 1.58e+07. What is the ratio of the Aid flow (current US$) in Europe(developing only) in 1998 to that in 1999?
Give a very brief answer. 0.41. What is the ratio of the Aid flow (current US$) of Latin America(developing only) in 1998 to that in 1999?
Your answer should be compact. 1.29. What is the ratio of the Aid flow (current US$) of Small states in 1998 to that in 1999?
Give a very brief answer. 1.96. What is the ratio of the Aid flow (current US$) in Bhutan in 1998 to that in 1999?
Make the answer very short. 3.94. What is the ratio of the Aid flow (current US$) in Europe(developing only) in 1998 to that in 2000?
Make the answer very short. 0.57. What is the ratio of the Aid flow (current US$) of Latin America(developing only) in 1998 to that in 2000?
Make the answer very short. 1.53. What is the ratio of the Aid flow (current US$) of Small states in 1998 to that in 2000?
Give a very brief answer. 0.98. What is the ratio of the Aid flow (current US$) of Bhutan in 1998 to that in 2000?
Offer a terse response. 1.83. What is the ratio of the Aid flow (current US$) of Europe(developing only) in 1998 to that in 2001?
Make the answer very short. 0.86. What is the ratio of the Aid flow (current US$) in Latin America(developing only) in 1998 to that in 2001?
Ensure brevity in your answer.  1.04. What is the ratio of the Aid flow (current US$) in Small states in 1998 to that in 2001?
Your answer should be very brief. 1.33. What is the ratio of the Aid flow (current US$) of Bhutan in 1998 to that in 2001?
Provide a short and direct response. 4. What is the ratio of the Aid flow (current US$) of Europe(developing only) in 1998 to that in 2002?
Your response must be concise. 0.5. What is the ratio of the Aid flow (current US$) in Latin America(developing only) in 1998 to that in 2002?
Your response must be concise. 1.5. What is the ratio of the Aid flow (current US$) in Bhutan in 1998 to that in 2002?
Your answer should be very brief. 2.4. What is the ratio of the Aid flow (current US$) of Europe(developing only) in 1998 to that in 2003?
Offer a very short reply. 0.52. What is the ratio of the Aid flow (current US$) of Latin America(developing only) in 1998 to that in 2003?
Your answer should be compact. 1.21. What is the ratio of the Aid flow (current US$) of Small states in 1998 to that in 2003?
Give a very brief answer. 1.24. What is the ratio of the Aid flow (current US$) in Bhutan in 1998 to that in 2003?
Give a very brief answer. 2.05. What is the ratio of the Aid flow (current US$) in Europe(developing only) in 1998 to that in 2004?
Your answer should be compact. 0.6. What is the ratio of the Aid flow (current US$) of Latin America(developing only) in 1998 to that in 2004?
Ensure brevity in your answer.  1.03. What is the ratio of the Aid flow (current US$) of Small states in 1998 to that in 2004?
Offer a very short reply. 1.16. What is the ratio of the Aid flow (current US$) in Bhutan in 1998 to that in 2004?
Make the answer very short. 3. What is the ratio of the Aid flow (current US$) in Europe(developing only) in 1999 to that in 2000?
Ensure brevity in your answer.  1.37. What is the ratio of the Aid flow (current US$) in Latin America(developing only) in 1999 to that in 2000?
Ensure brevity in your answer.  1.18. What is the ratio of the Aid flow (current US$) in Small states in 1999 to that in 2000?
Offer a very short reply. 0.5. What is the ratio of the Aid flow (current US$) of Bhutan in 1999 to that in 2000?
Offer a terse response. 0.47. What is the ratio of the Aid flow (current US$) of Europe(developing only) in 1999 to that in 2001?
Offer a terse response. 2.06. What is the ratio of the Aid flow (current US$) in Latin America(developing only) in 1999 to that in 2001?
Your answer should be very brief. 0.81. What is the ratio of the Aid flow (current US$) of Small states in 1999 to that in 2001?
Ensure brevity in your answer.  0.68. What is the ratio of the Aid flow (current US$) in Bhutan in 1999 to that in 2001?
Keep it short and to the point. 1.02. What is the ratio of the Aid flow (current US$) in Europe(developing only) in 1999 to that in 2002?
Your answer should be compact. 1.21. What is the ratio of the Aid flow (current US$) in Latin America(developing only) in 1999 to that in 2002?
Your response must be concise. 1.17. What is the ratio of the Aid flow (current US$) of Small states in 1999 to that in 2002?
Your answer should be compact. 0.51. What is the ratio of the Aid flow (current US$) of Bhutan in 1999 to that in 2002?
Your answer should be very brief. 0.61. What is the ratio of the Aid flow (current US$) in Europe(developing only) in 1999 to that in 2003?
Your answer should be very brief. 1.24. What is the ratio of the Aid flow (current US$) of Latin America(developing only) in 1999 to that in 2003?
Give a very brief answer. 0.94. What is the ratio of the Aid flow (current US$) of Small states in 1999 to that in 2003?
Your response must be concise. 0.63. What is the ratio of the Aid flow (current US$) in Bhutan in 1999 to that in 2003?
Keep it short and to the point. 0.52. What is the ratio of the Aid flow (current US$) in Europe(developing only) in 1999 to that in 2004?
Keep it short and to the point. 1.45. What is the ratio of the Aid flow (current US$) in Latin America(developing only) in 1999 to that in 2004?
Provide a succinct answer. 0.8. What is the ratio of the Aid flow (current US$) of Small states in 1999 to that in 2004?
Keep it short and to the point. 0.59. What is the ratio of the Aid flow (current US$) of Bhutan in 1999 to that in 2004?
Provide a short and direct response. 0.76. What is the ratio of the Aid flow (current US$) of Europe(developing only) in 2000 to that in 2001?
Your response must be concise. 1.51. What is the ratio of the Aid flow (current US$) in Latin America(developing only) in 2000 to that in 2001?
Provide a succinct answer. 0.68. What is the ratio of the Aid flow (current US$) of Small states in 2000 to that in 2001?
Offer a very short reply. 1.36. What is the ratio of the Aid flow (current US$) of Bhutan in 2000 to that in 2001?
Offer a very short reply. 2.18. What is the ratio of the Aid flow (current US$) of Europe(developing only) in 2000 to that in 2002?
Ensure brevity in your answer.  0.89. What is the ratio of the Aid flow (current US$) in Latin America(developing only) in 2000 to that in 2002?
Make the answer very short. 0.98. What is the ratio of the Aid flow (current US$) in Bhutan in 2000 to that in 2002?
Ensure brevity in your answer.  1.31. What is the ratio of the Aid flow (current US$) in Europe(developing only) in 2000 to that in 2003?
Your answer should be very brief. 0.91. What is the ratio of the Aid flow (current US$) in Latin America(developing only) in 2000 to that in 2003?
Provide a short and direct response. 0.79. What is the ratio of the Aid flow (current US$) of Small states in 2000 to that in 2003?
Provide a short and direct response. 1.27. What is the ratio of the Aid flow (current US$) in Bhutan in 2000 to that in 2003?
Give a very brief answer. 1.12. What is the ratio of the Aid flow (current US$) of Europe(developing only) in 2000 to that in 2004?
Offer a terse response. 1.06. What is the ratio of the Aid flow (current US$) of Latin America(developing only) in 2000 to that in 2004?
Provide a succinct answer. 0.68. What is the ratio of the Aid flow (current US$) in Small states in 2000 to that in 2004?
Your answer should be compact. 1.19. What is the ratio of the Aid flow (current US$) of Bhutan in 2000 to that in 2004?
Your answer should be very brief. 1.64. What is the ratio of the Aid flow (current US$) in Europe(developing only) in 2001 to that in 2002?
Provide a succinct answer. 0.59. What is the ratio of the Aid flow (current US$) of Latin America(developing only) in 2001 to that in 2002?
Provide a succinct answer. 1.45. What is the ratio of the Aid flow (current US$) in Small states in 2001 to that in 2002?
Offer a terse response. 0.75. What is the ratio of the Aid flow (current US$) of Bhutan in 2001 to that in 2002?
Offer a very short reply. 0.6. What is the ratio of the Aid flow (current US$) in Europe(developing only) in 2001 to that in 2003?
Provide a succinct answer. 0.6. What is the ratio of the Aid flow (current US$) of Latin America(developing only) in 2001 to that in 2003?
Offer a very short reply. 1.17. What is the ratio of the Aid flow (current US$) of Small states in 2001 to that in 2003?
Your answer should be very brief. 0.93. What is the ratio of the Aid flow (current US$) in Bhutan in 2001 to that in 2003?
Provide a short and direct response. 0.51. What is the ratio of the Aid flow (current US$) of Europe(developing only) in 2001 to that in 2004?
Your answer should be compact. 0.7. What is the ratio of the Aid flow (current US$) in Latin America(developing only) in 2001 to that in 2004?
Offer a very short reply. 1. What is the ratio of the Aid flow (current US$) of Small states in 2001 to that in 2004?
Ensure brevity in your answer.  0.87. What is the ratio of the Aid flow (current US$) of Bhutan in 2001 to that in 2004?
Your answer should be compact. 0.75. What is the ratio of the Aid flow (current US$) of Europe(developing only) in 2002 to that in 2003?
Offer a terse response. 1.03. What is the ratio of the Aid flow (current US$) of Latin America(developing only) in 2002 to that in 2003?
Make the answer very short. 0.81. What is the ratio of the Aid flow (current US$) in Small states in 2002 to that in 2003?
Offer a terse response. 1.25. What is the ratio of the Aid flow (current US$) in Bhutan in 2002 to that in 2003?
Your answer should be compact. 0.85. What is the ratio of the Aid flow (current US$) in Europe(developing only) in 2002 to that in 2004?
Provide a short and direct response. 1.2. What is the ratio of the Aid flow (current US$) in Latin America(developing only) in 2002 to that in 2004?
Offer a terse response. 0.69. What is the ratio of the Aid flow (current US$) of Small states in 2002 to that in 2004?
Ensure brevity in your answer.  1.17. What is the ratio of the Aid flow (current US$) of Bhutan in 2002 to that in 2004?
Your answer should be very brief. 1.25. What is the ratio of the Aid flow (current US$) in Europe(developing only) in 2003 to that in 2004?
Ensure brevity in your answer.  1.16. What is the ratio of the Aid flow (current US$) in Latin America(developing only) in 2003 to that in 2004?
Ensure brevity in your answer.  0.85. What is the ratio of the Aid flow (current US$) in Small states in 2003 to that in 2004?
Ensure brevity in your answer.  0.93. What is the ratio of the Aid flow (current US$) of Bhutan in 2003 to that in 2004?
Keep it short and to the point. 1.47. What is the difference between the highest and the second highest Aid flow (current US$) in Europe(developing only)?
Keep it short and to the point. 3.04e+07. What is the difference between the highest and the second highest Aid flow (current US$) in Latin America(developing only)?
Provide a succinct answer. 3.01e+06. What is the difference between the highest and the second highest Aid flow (current US$) in Small states?
Give a very brief answer. 3.30e+05. What is the difference between the highest and the second highest Aid flow (current US$) in Bhutan?
Provide a succinct answer. 1.20e+06. What is the difference between the highest and the lowest Aid flow (current US$) of Europe(developing only)?
Give a very brief answer. 1.02e+08. What is the difference between the highest and the lowest Aid flow (current US$) of Latin America(developing only)?
Your response must be concise. 3.10e+07. What is the difference between the highest and the lowest Aid flow (current US$) in Small states?
Provide a succinct answer. 9.88e+06. What is the difference between the highest and the lowest Aid flow (current US$) of Bhutan?
Your answer should be compact. 1.98e+06. 